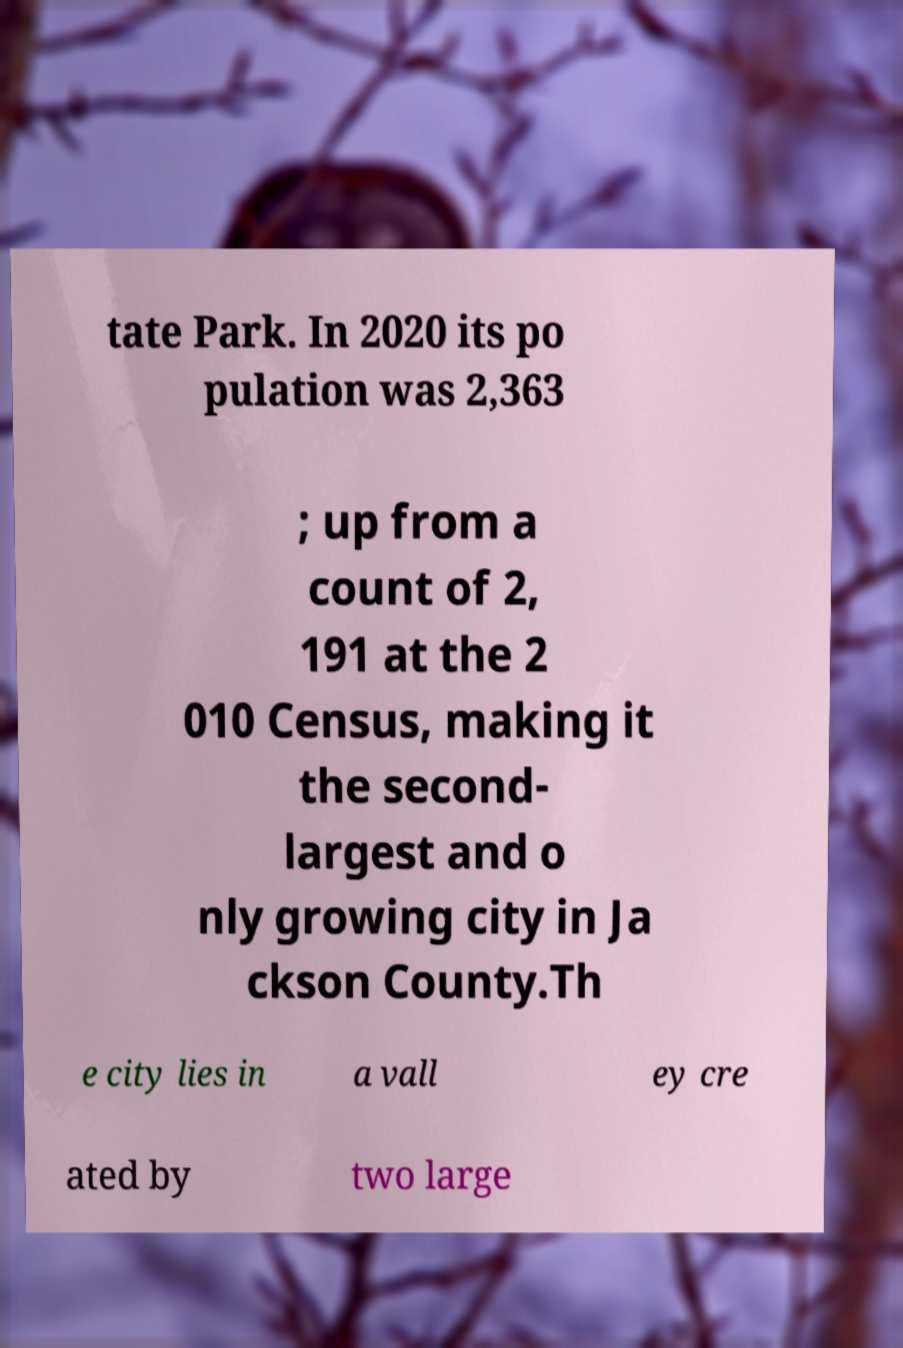For documentation purposes, I need the text within this image transcribed. Could you provide that? tate Park. In 2020 its po pulation was 2,363 ; up from a count of 2, 191 at the 2 010 Census, making it the second- largest and o nly growing city in Ja ckson County.Th e city lies in a vall ey cre ated by two large 